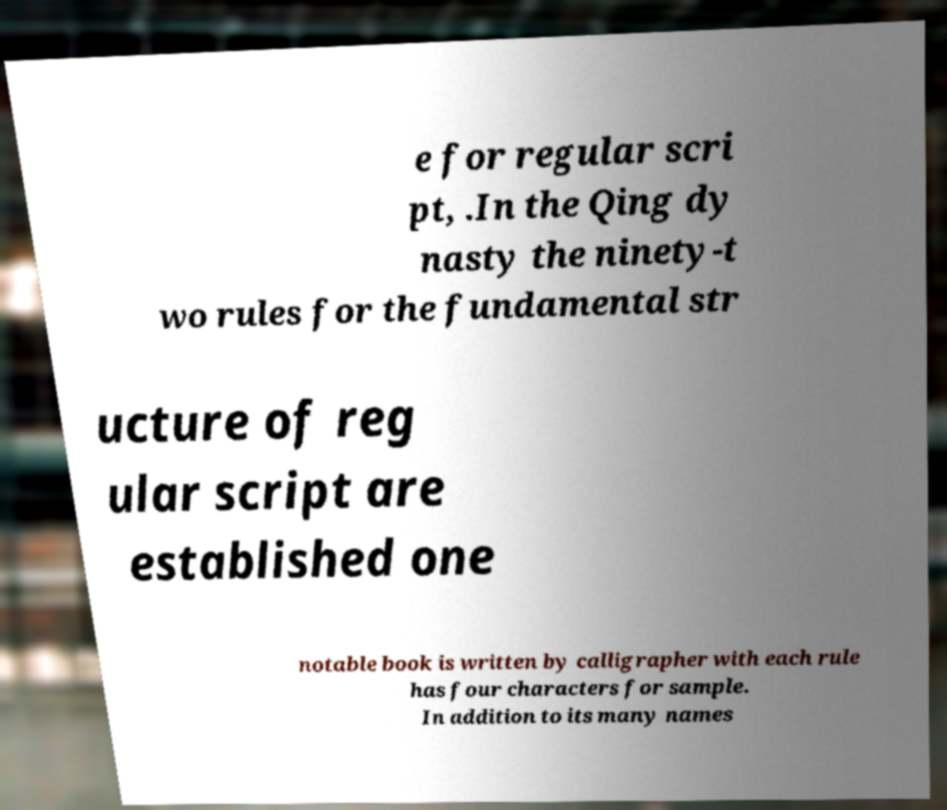Could you extract and type out the text from this image? e for regular scri pt, .In the Qing dy nasty the ninety-t wo rules for the fundamental str ucture of reg ular script are established one notable book is written by calligrapher with each rule has four characters for sample. In addition to its many names 